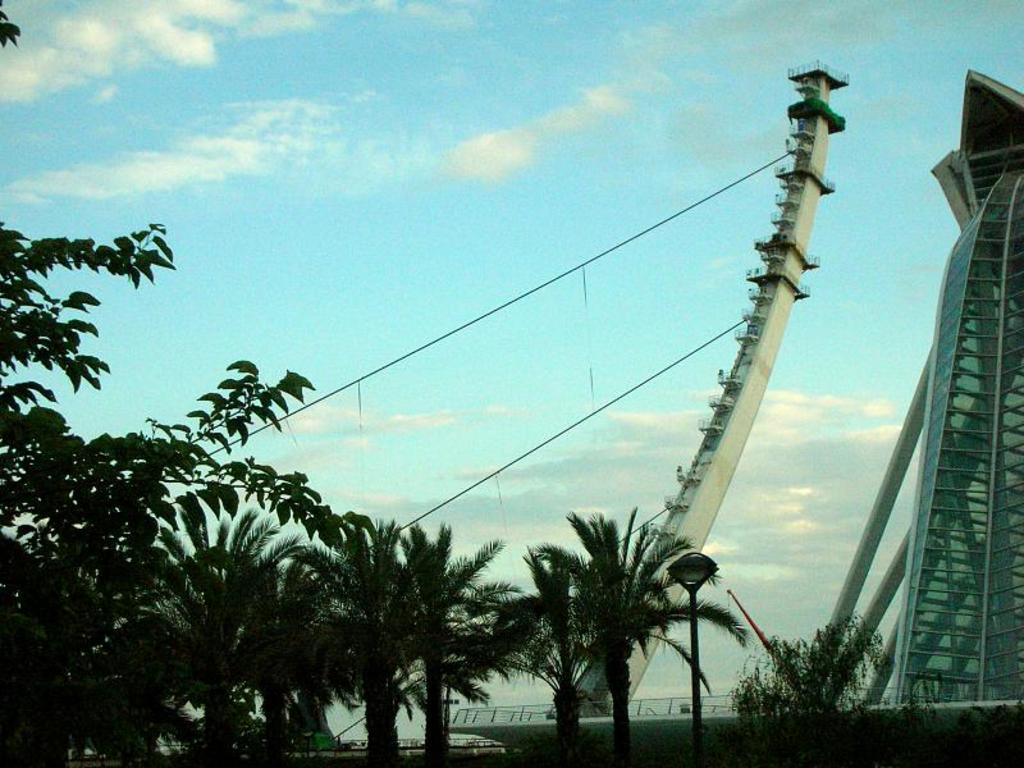What type of structures can be seen in the image? There are buildings in the image. What natural elements are present in the image? There are many trees in the image. Are there any man-made elements visible in the image besides the buildings? Yes, there are cables visible in the image. What is the condition of the sky in the image? The sky contains clouds in the image. How much salt is sprinkled on the trees in the image? There is no salt present in the image; it is a natural scene with trees and buildings. 